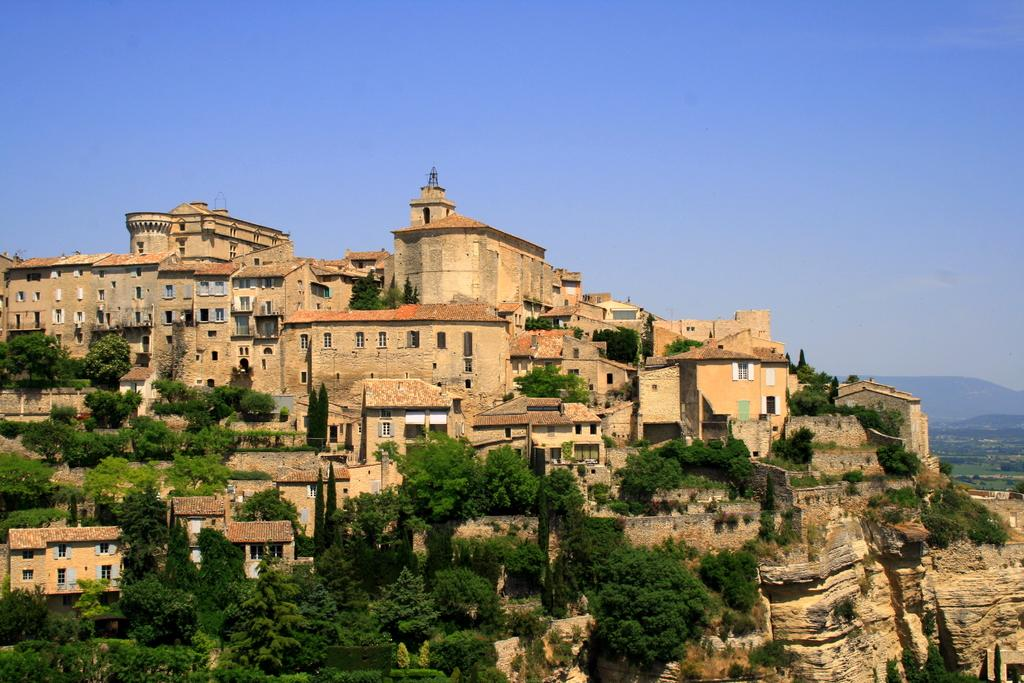What type of structures can be seen in the image? There are buildings in the image. What type of vegetation is present in the image? There are trees and grass in the image. What type of natural landform is visible in the image? There are mountains in the image. What part of the natural environment is visible in the image? The sky is visible in the image. What type of floor can be seen in the image? There is no floor present in the image; it features buildings, trees, grass, mountains, and the sky. Is there any snow visible in the image? There is no snow present in the image; it features buildings, trees, grass, mountains, and the sky. 